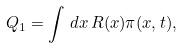Convert formula to latex. <formula><loc_0><loc_0><loc_500><loc_500>Q _ { 1 } = \int \, d { x } \, R ( { x } ) \pi ( { x } , t ) ,</formula> 